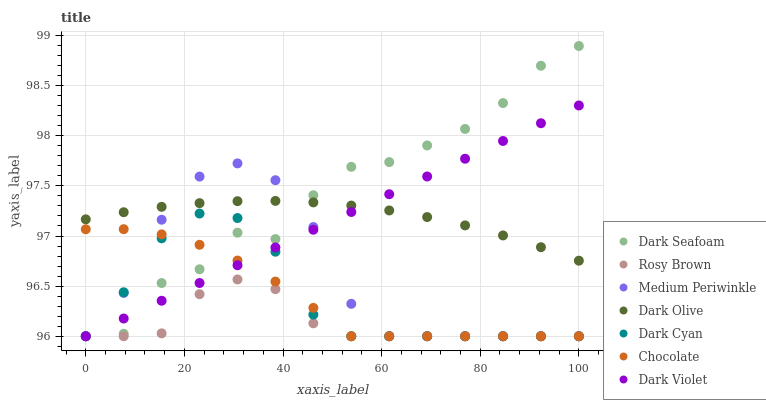Does Rosy Brown have the minimum area under the curve?
Answer yes or no. Yes. Does Dark Seafoam have the maximum area under the curve?
Answer yes or no. Yes. Does Dark Olive have the minimum area under the curve?
Answer yes or no. No. Does Dark Olive have the maximum area under the curve?
Answer yes or no. No. Is Dark Violet the smoothest?
Answer yes or no. Yes. Is Dark Seafoam the roughest?
Answer yes or no. Yes. Is Dark Olive the smoothest?
Answer yes or no. No. Is Dark Olive the roughest?
Answer yes or no. No. Does Rosy Brown have the lowest value?
Answer yes or no. Yes. Does Dark Olive have the lowest value?
Answer yes or no. No. Does Dark Seafoam have the highest value?
Answer yes or no. Yes. Does Dark Olive have the highest value?
Answer yes or no. No. Is Chocolate less than Dark Olive?
Answer yes or no. Yes. Is Dark Olive greater than Dark Cyan?
Answer yes or no. Yes. Does Chocolate intersect Medium Periwinkle?
Answer yes or no. Yes. Is Chocolate less than Medium Periwinkle?
Answer yes or no. No. Is Chocolate greater than Medium Periwinkle?
Answer yes or no. No. Does Chocolate intersect Dark Olive?
Answer yes or no. No. 